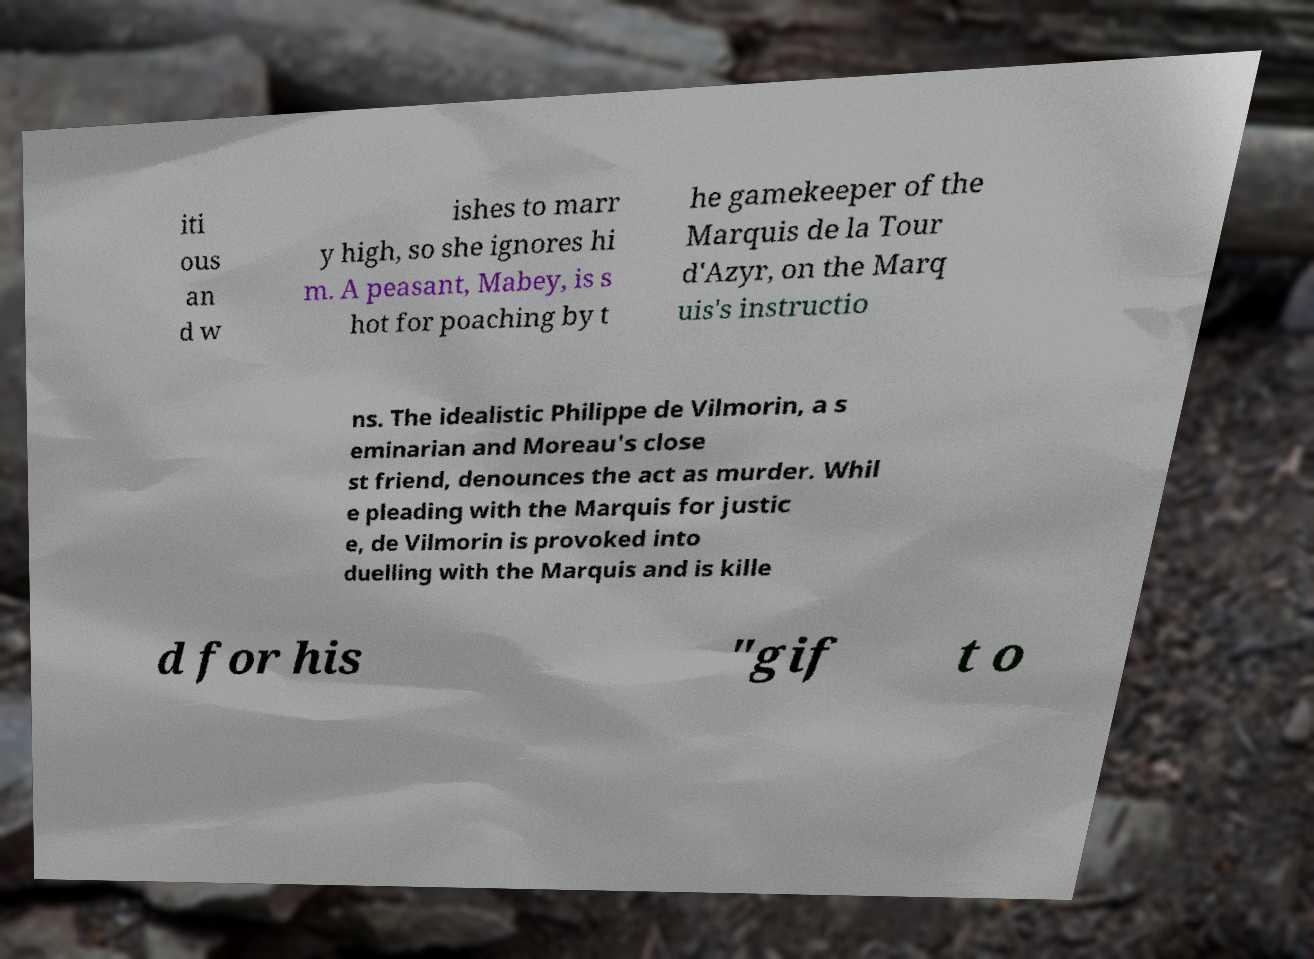Could you assist in decoding the text presented in this image and type it out clearly? iti ous an d w ishes to marr y high, so she ignores hi m. A peasant, Mabey, is s hot for poaching by t he gamekeeper of the Marquis de la Tour d'Azyr, on the Marq uis's instructio ns. The idealistic Philippe de Vilmorin, a s eminarian and Moreau's close st friend, denounces the act as murder. Whil e pleading with the Marquis for justic e, de Vilmorin is provoked into duelling with the Marquis and is kille d for his "gif t o 